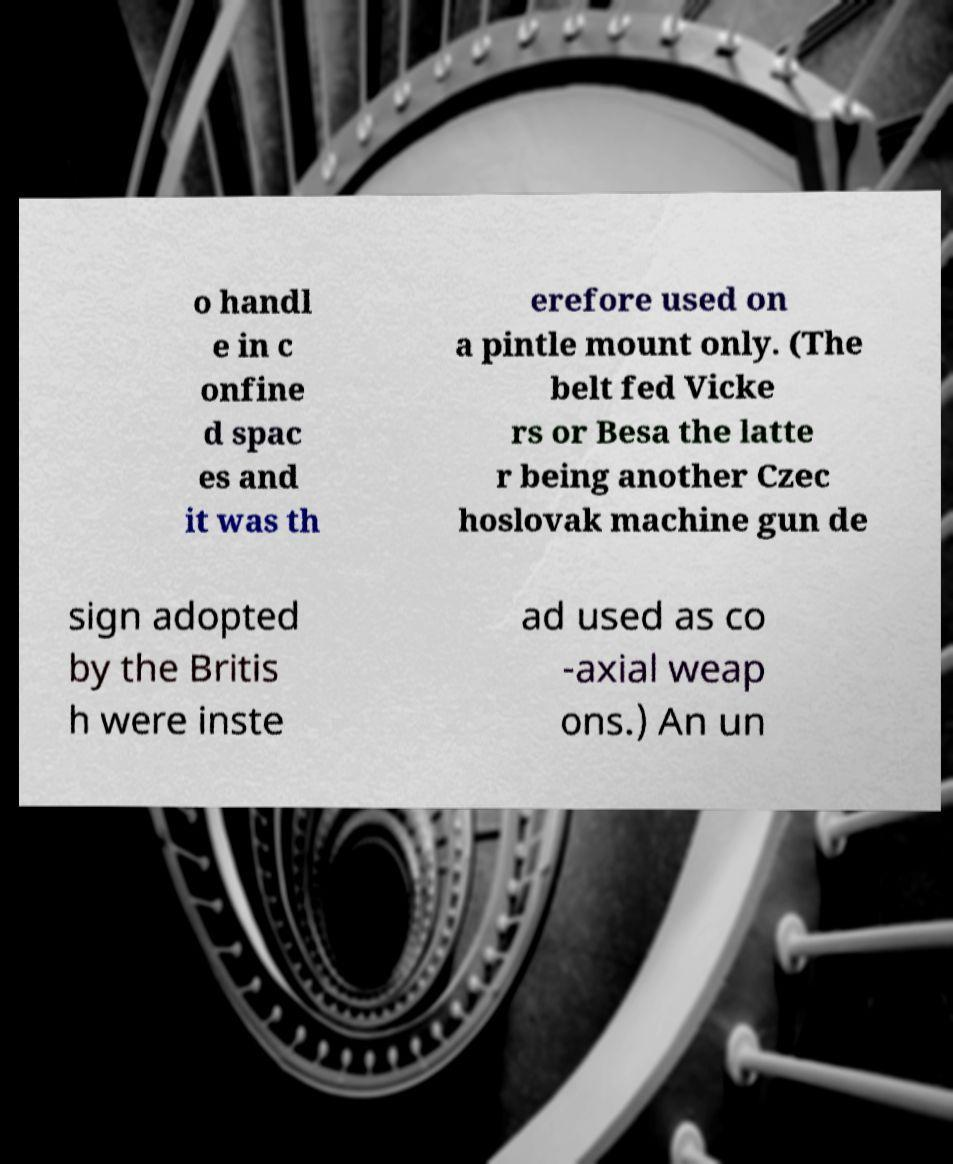Can you read and provide the text displayed in the image?This photo seems to have some interesting text. Can you extract and type it out for me? o handl e in c onfine d spac es and it was th erefore used on a pintle mount only. (The belt fed Vicke rs or Besa the latte r being another Czec hoslovak machine gun de sign adopted by the Britis h were inste ad used as co -axial weap ons.) An un 